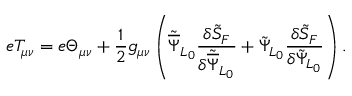<formula> <loc_0><loc_0><loc_500><loc_500>e T _ { \mu \nu } = e \Theta _ { \mu \nu } + \frac { 1 } { 2 } g _ { \mu \nu } \left ( { \tilde { \overline { \Psi } } } _ { L _ { 0 } } \frac { \delta { \tilde { S } } _ { F } } { \delta { \tilde { \overline { \Psi } } } _ { L _ { 0 } } } + { \tilde { \Psi } } _ { L _ { 0 } } \frac { \delta { \tilde { S } } _ { F } } { \delta { \tilde { \Psi } } _ { L _ { 0 } } } \right ) .</formula> 